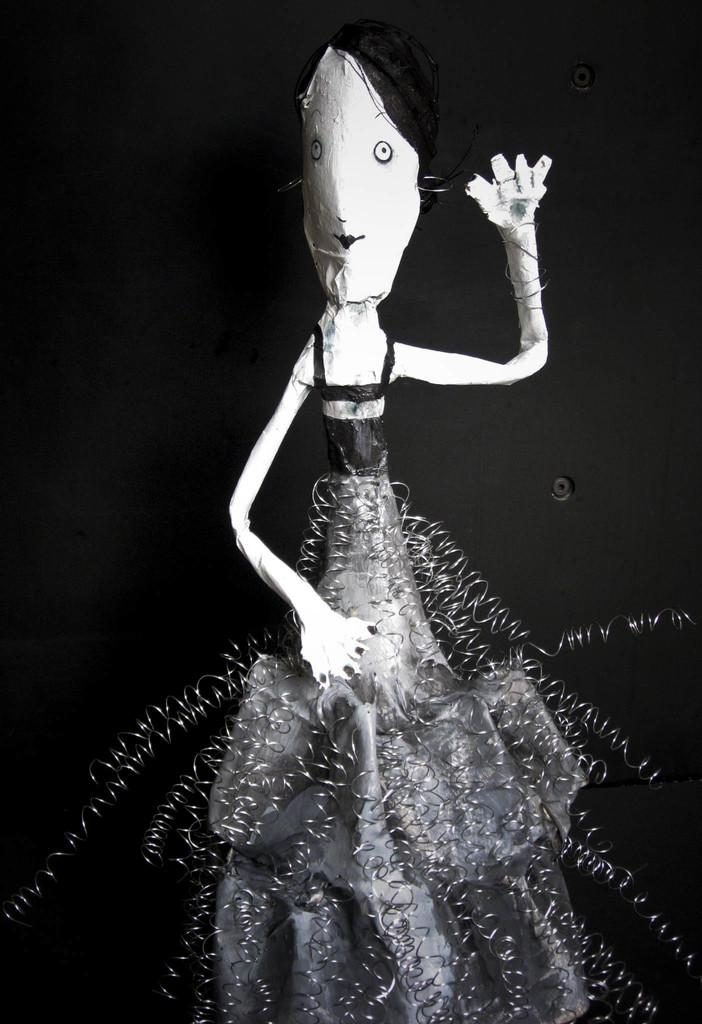What is the main subject of the image? There is a doll in the image. What materials were used to make the doll? The doll is made from paper, springs, and a plastic cover. Can you describe the background of the image? The background of the image appears to be dark. How many boys are present in the image? There are no boys present in the image; it features a doll made from paper, springs, and a plastic cover. What company is responsible for creating the doll in the image? There is no information about the company responsible for creating the doll in the image. 